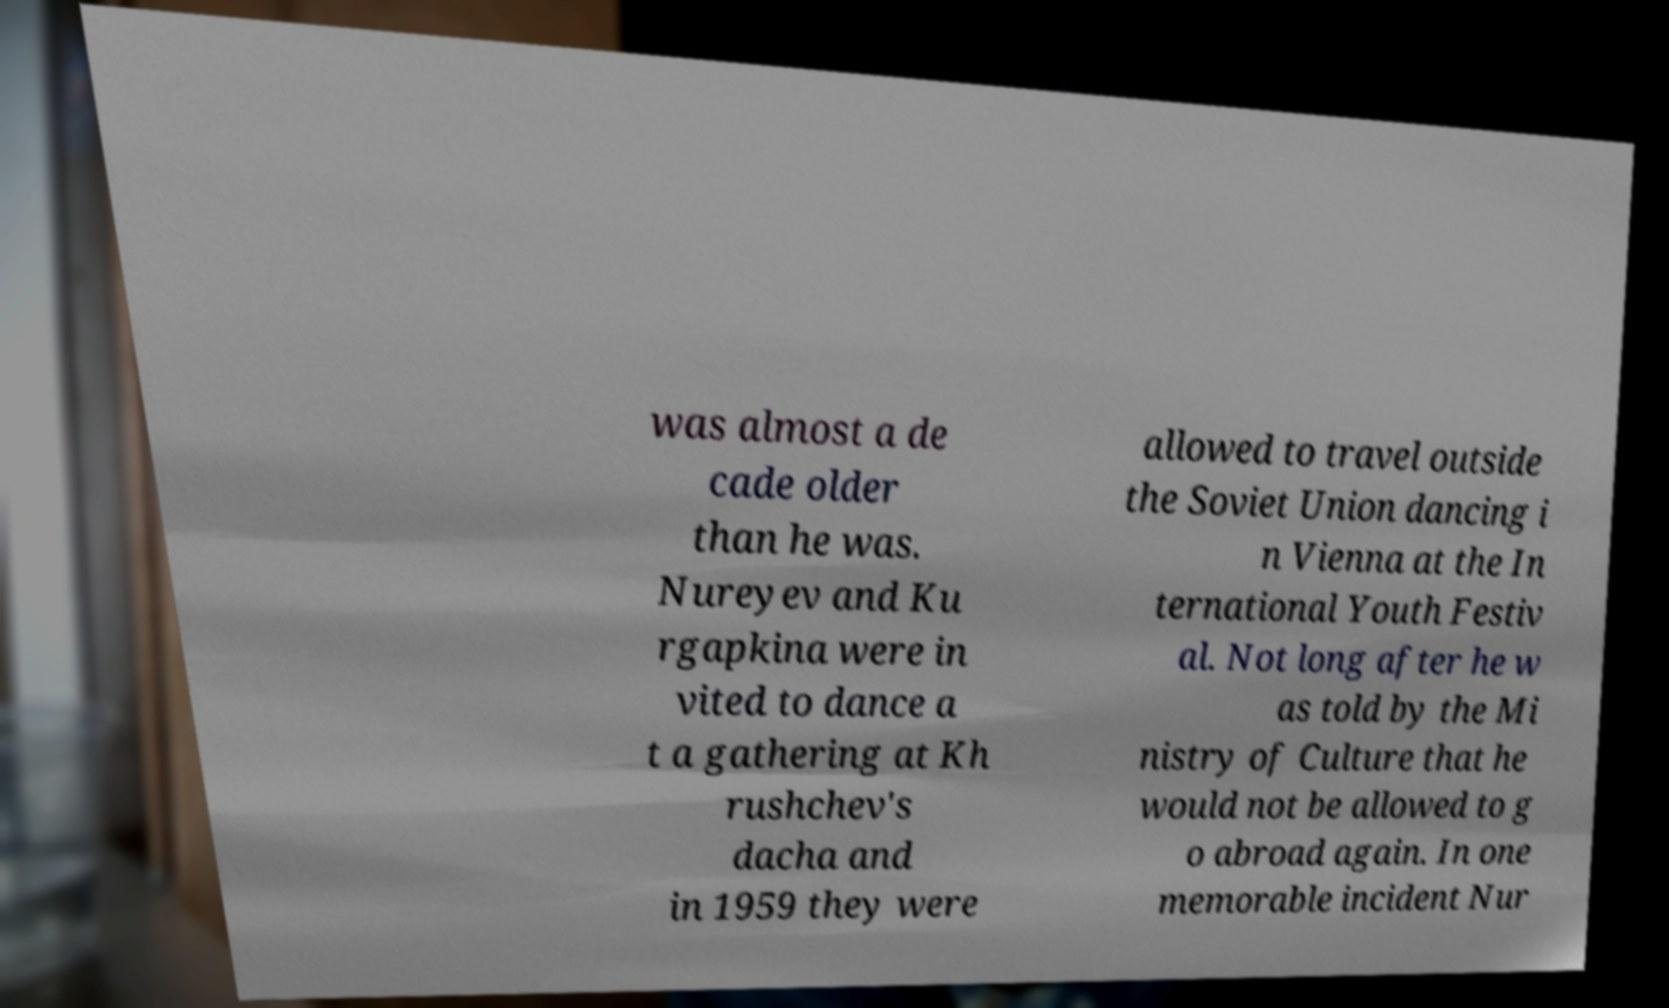Can you read and provide the text displayed in the image?This photo seems to have some interesting text. Can you extract and type it out for me? was almost a de cade older than he was. Nureyev and Ku rgapkina were in vited to dance a t a gathering at Kh rushchev's dacha and in 1959 they were allowed to travel outside the Soviet Union dancing i n Vienna at the In ternational Youth Festiv al. Not long after he w as told by the Mi nistry of Culture that he would not be allowed to g o abroad again. In one memorable incident Nur 